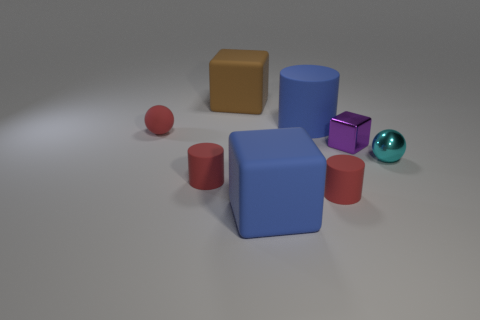What shape is the object that is both to the right of the large blue cylinder and on the left side of the purple object?
Offer a terse response. Cylinder. What number of objects are either small matte cylinders right of the big brown matte object or small things left of the small metal cube?
Your answer should be compact. 3. Are there the same number of small red matte balls that are behind the red rubber ball and big blue cylinders that are in front of the blue cylinder?
Your response must be concise. Yes. There is a small red object to the right of the rubber block in front of the big brown matte thing; what shape is it?
Your answer should be very brief. Cylinder. Is there a brown object that has the same shape as the small cyan thing?
Make the answer very short. No. How many blue blocks are there?
Ensure brevity in your answer.  1. Is the red sphere on the left side of the tiny purple metal cube made of the same material as the large blue cube?
Your answer should be compact. Yes. Are there any cyan cylinders of the same size as the purple object?
Give a very brief answer. No. There is a tiny cyan thing; does it have the same shape as the tiny matte thing that is behind the tiny purple object?
Offer a very short reply. Yes. Is there a cyan thing to the right of the cube to the left of the blue rubber cube in front of the blue rubber cylinder?
Make the answer very short. Yes. 